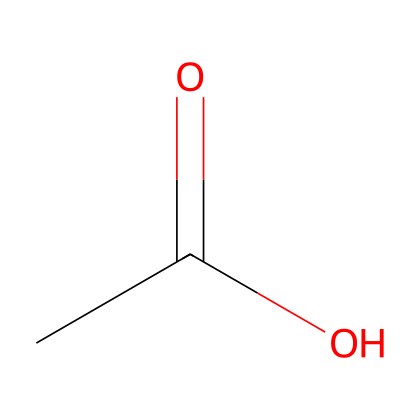How many carbon atoms are in acetic acid? The SMILES representation shows "CC", indicating two carbon atoms in the molecule.
Answer: 2 What is the chemical formula of acetic acid based on its structure? The structure implies one carbonyl group (C=O) and one hydroxyl group (O-H), giving the formula C2H4O2.
Answer: C2H4O2 What type of functional group is present in acetic acid? The presence of the carboxyl group (-COOH) in the molecule identifies it as an acid.
Answer: carboxyl How many hydrogen atoms are there in acetic acid? Counting the hydrogen atoms attached; there are 3 from the methyl group (CH3) and 1 from the hydroxyl group (-OH), totaling to 4.
Answer: 4 Why is acetic acid effective in cleaning? Its acidic property allows it to dissolve mineral deposits and grease. This is due to protons (H+) being released, making it a strong solvent for cleaning.
Answer: acidic property What is the main use of acetic acid in cooking? Acetic acid is primarily used for flavoring and preserving food, notably in vinegar. Its taste and preservative qualities are key applications in culinary practices.
Answer: flavoring and preserving food How does acetic acid contribute to the sour taste in vinegar? The protons released from the acidic functional group stimulate the sour taste receptors on the tongue, leading to the perception of sourness in vinegar.
Answer: protons 